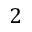Convert formula to latex. <formula><loc_0><loc_0><loc_500><loc_500>2</formula> 